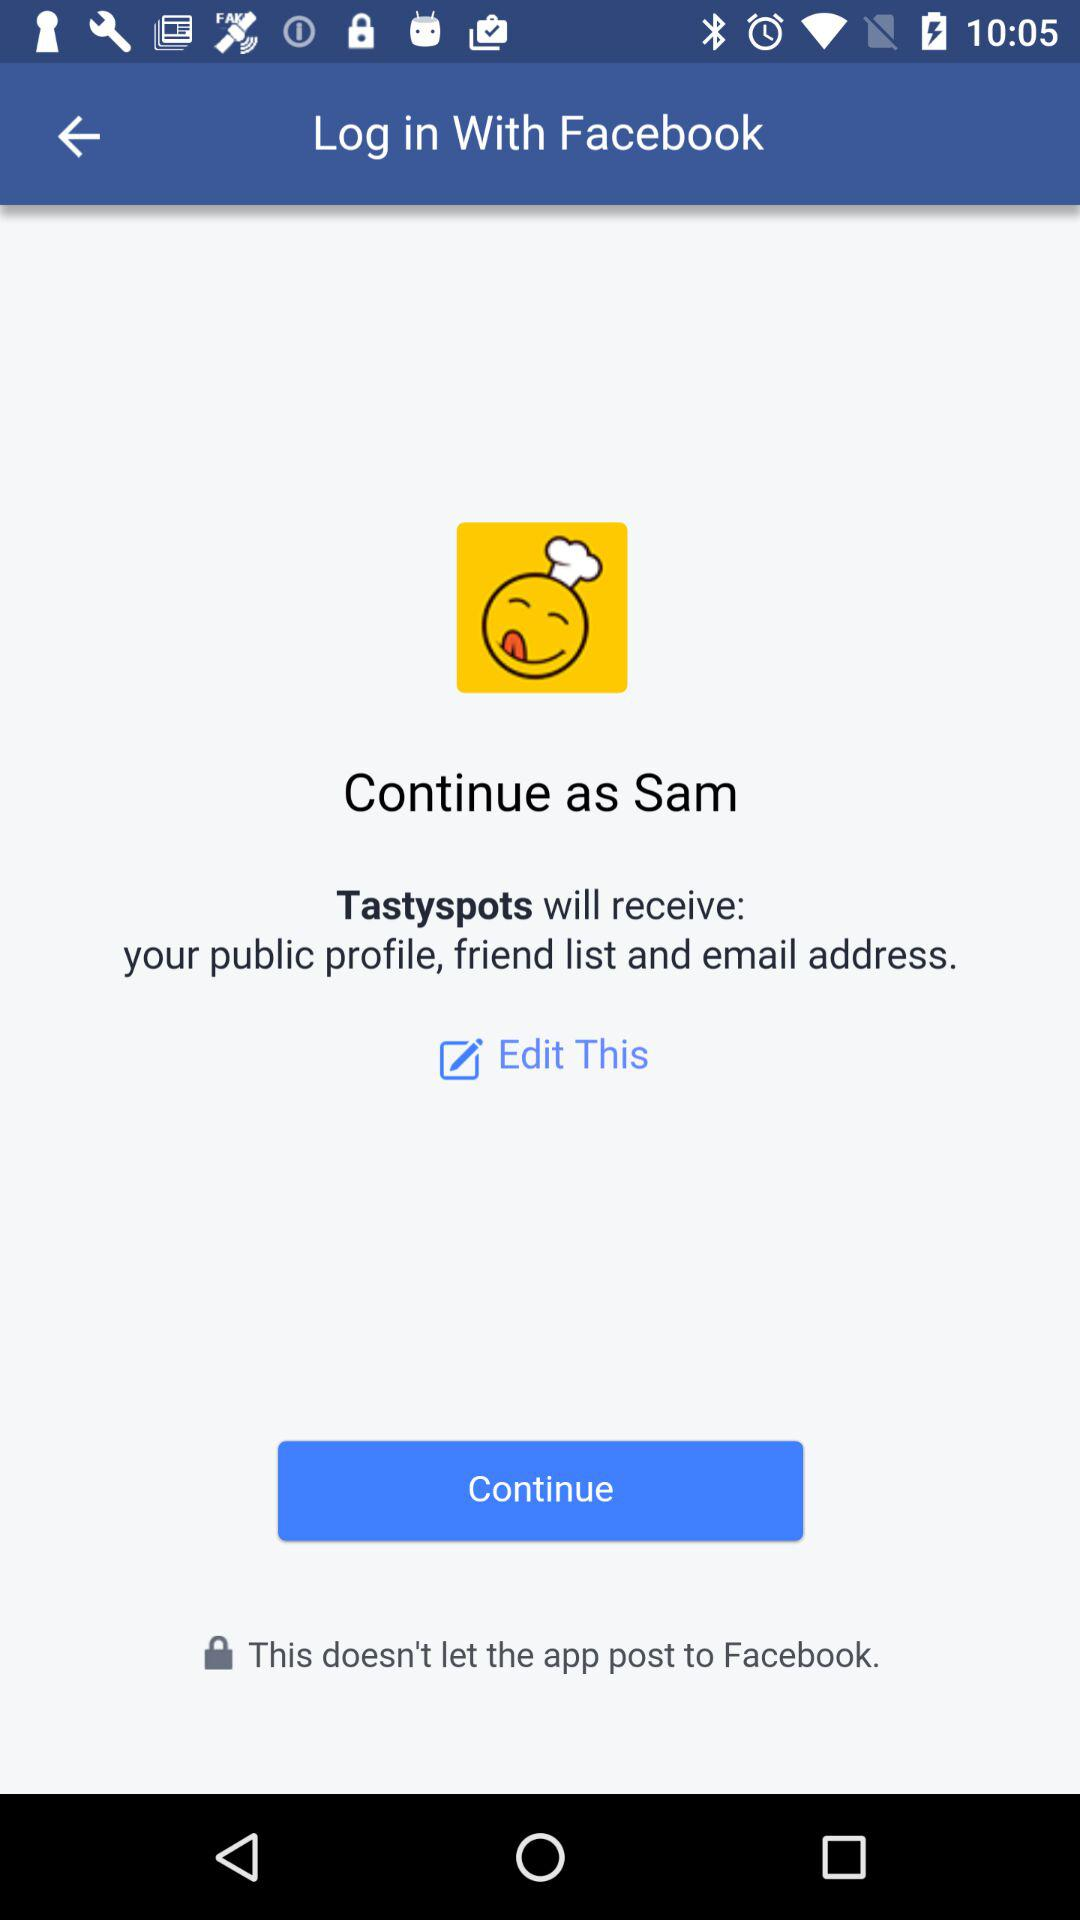What is the name of the user? The name of the user is Sam. 